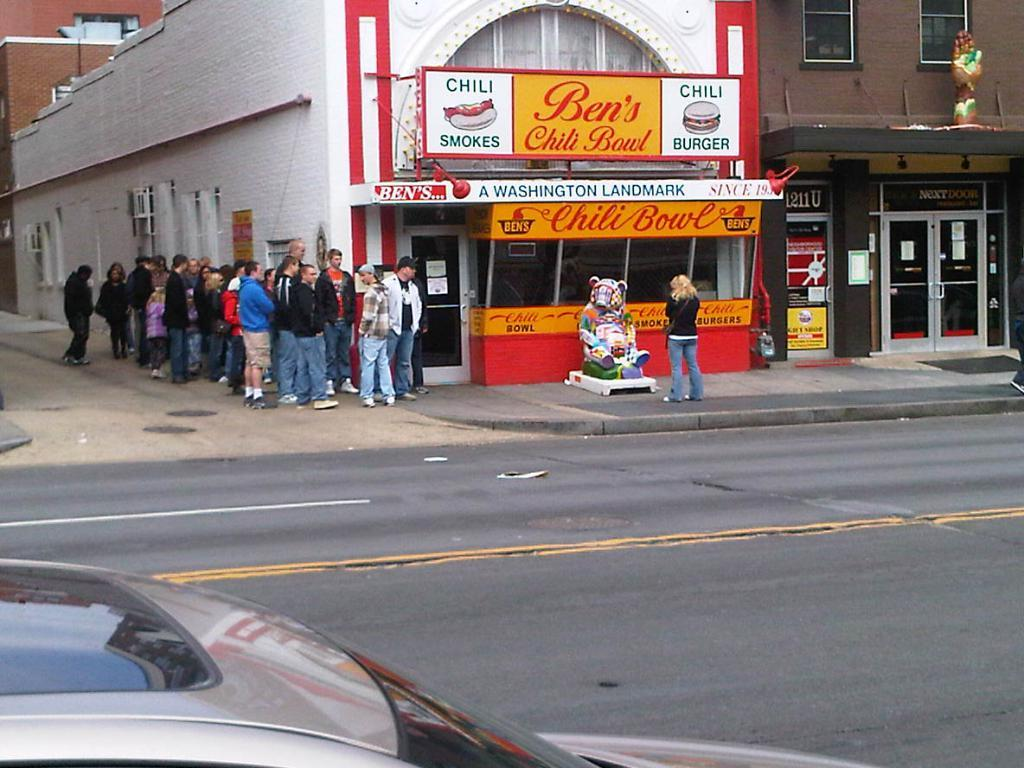<image>
Offer a succinct explanation of the picture presented. A crowd of people are gathered outside a restaurant with a sign that says Ben's Chili Bowl. 